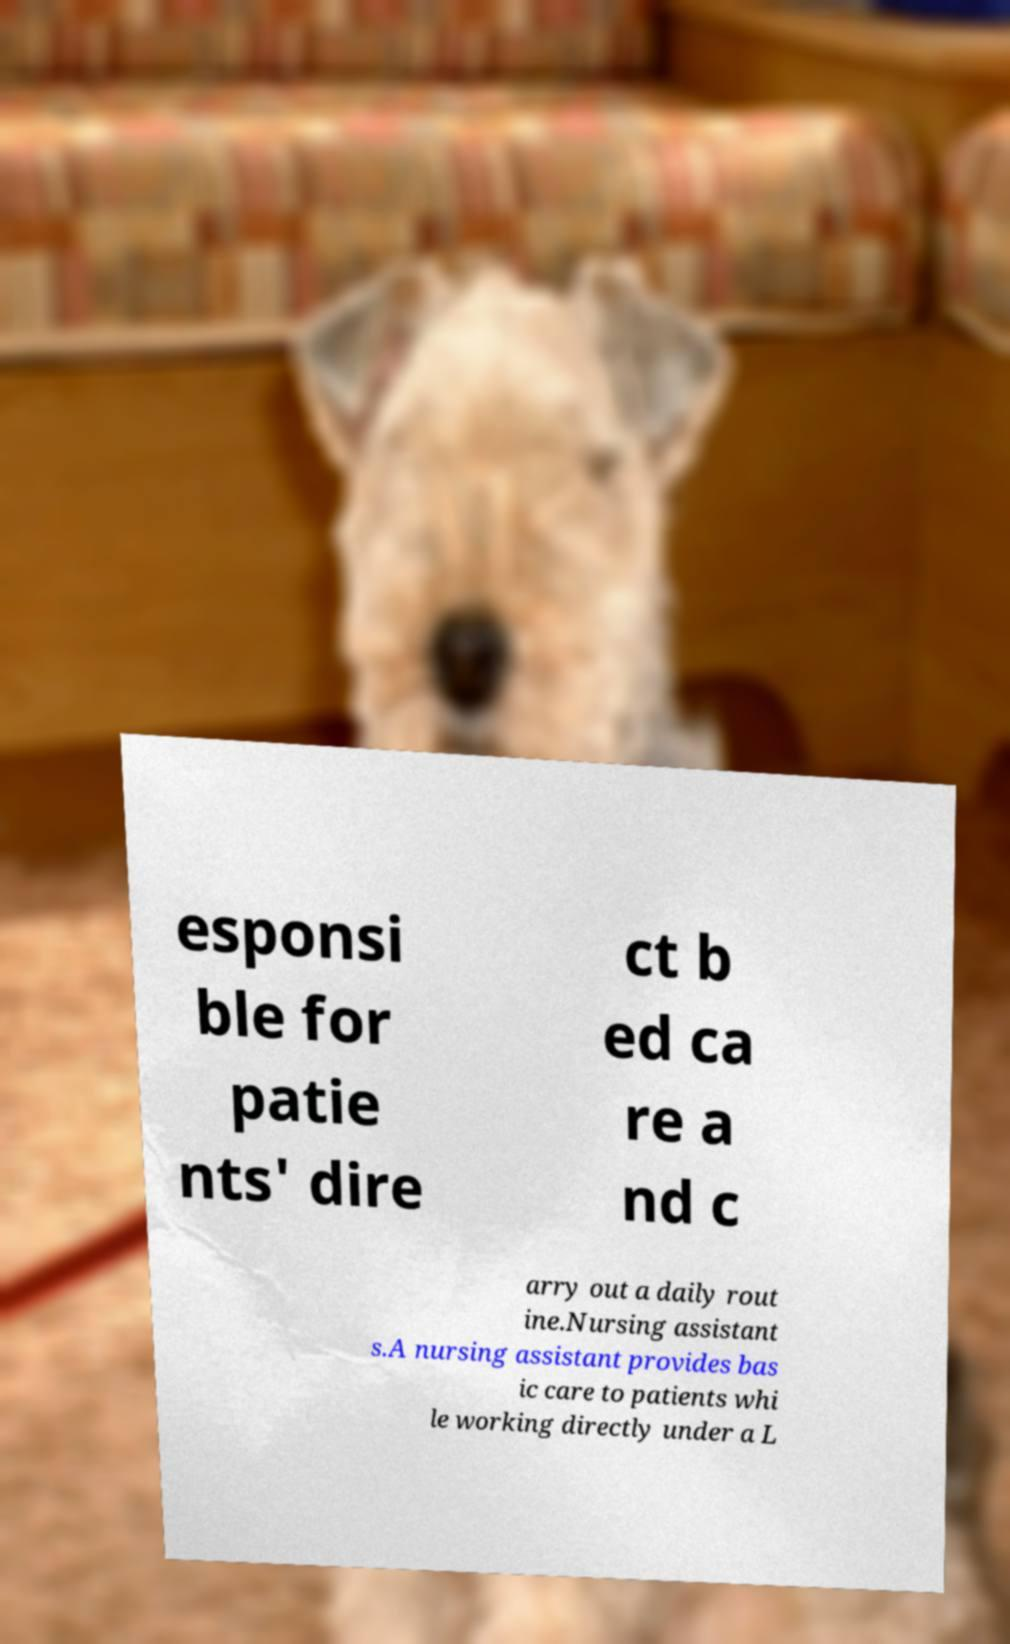Please read and relay the text visible in this image. What does it say? esponsi ble for patie nts' dire ct b ed ca re a nd c arry out a daily rout ine.Nursing assistant s.A nursing assistant provides bas ic care to patients whi le working directly under a L 